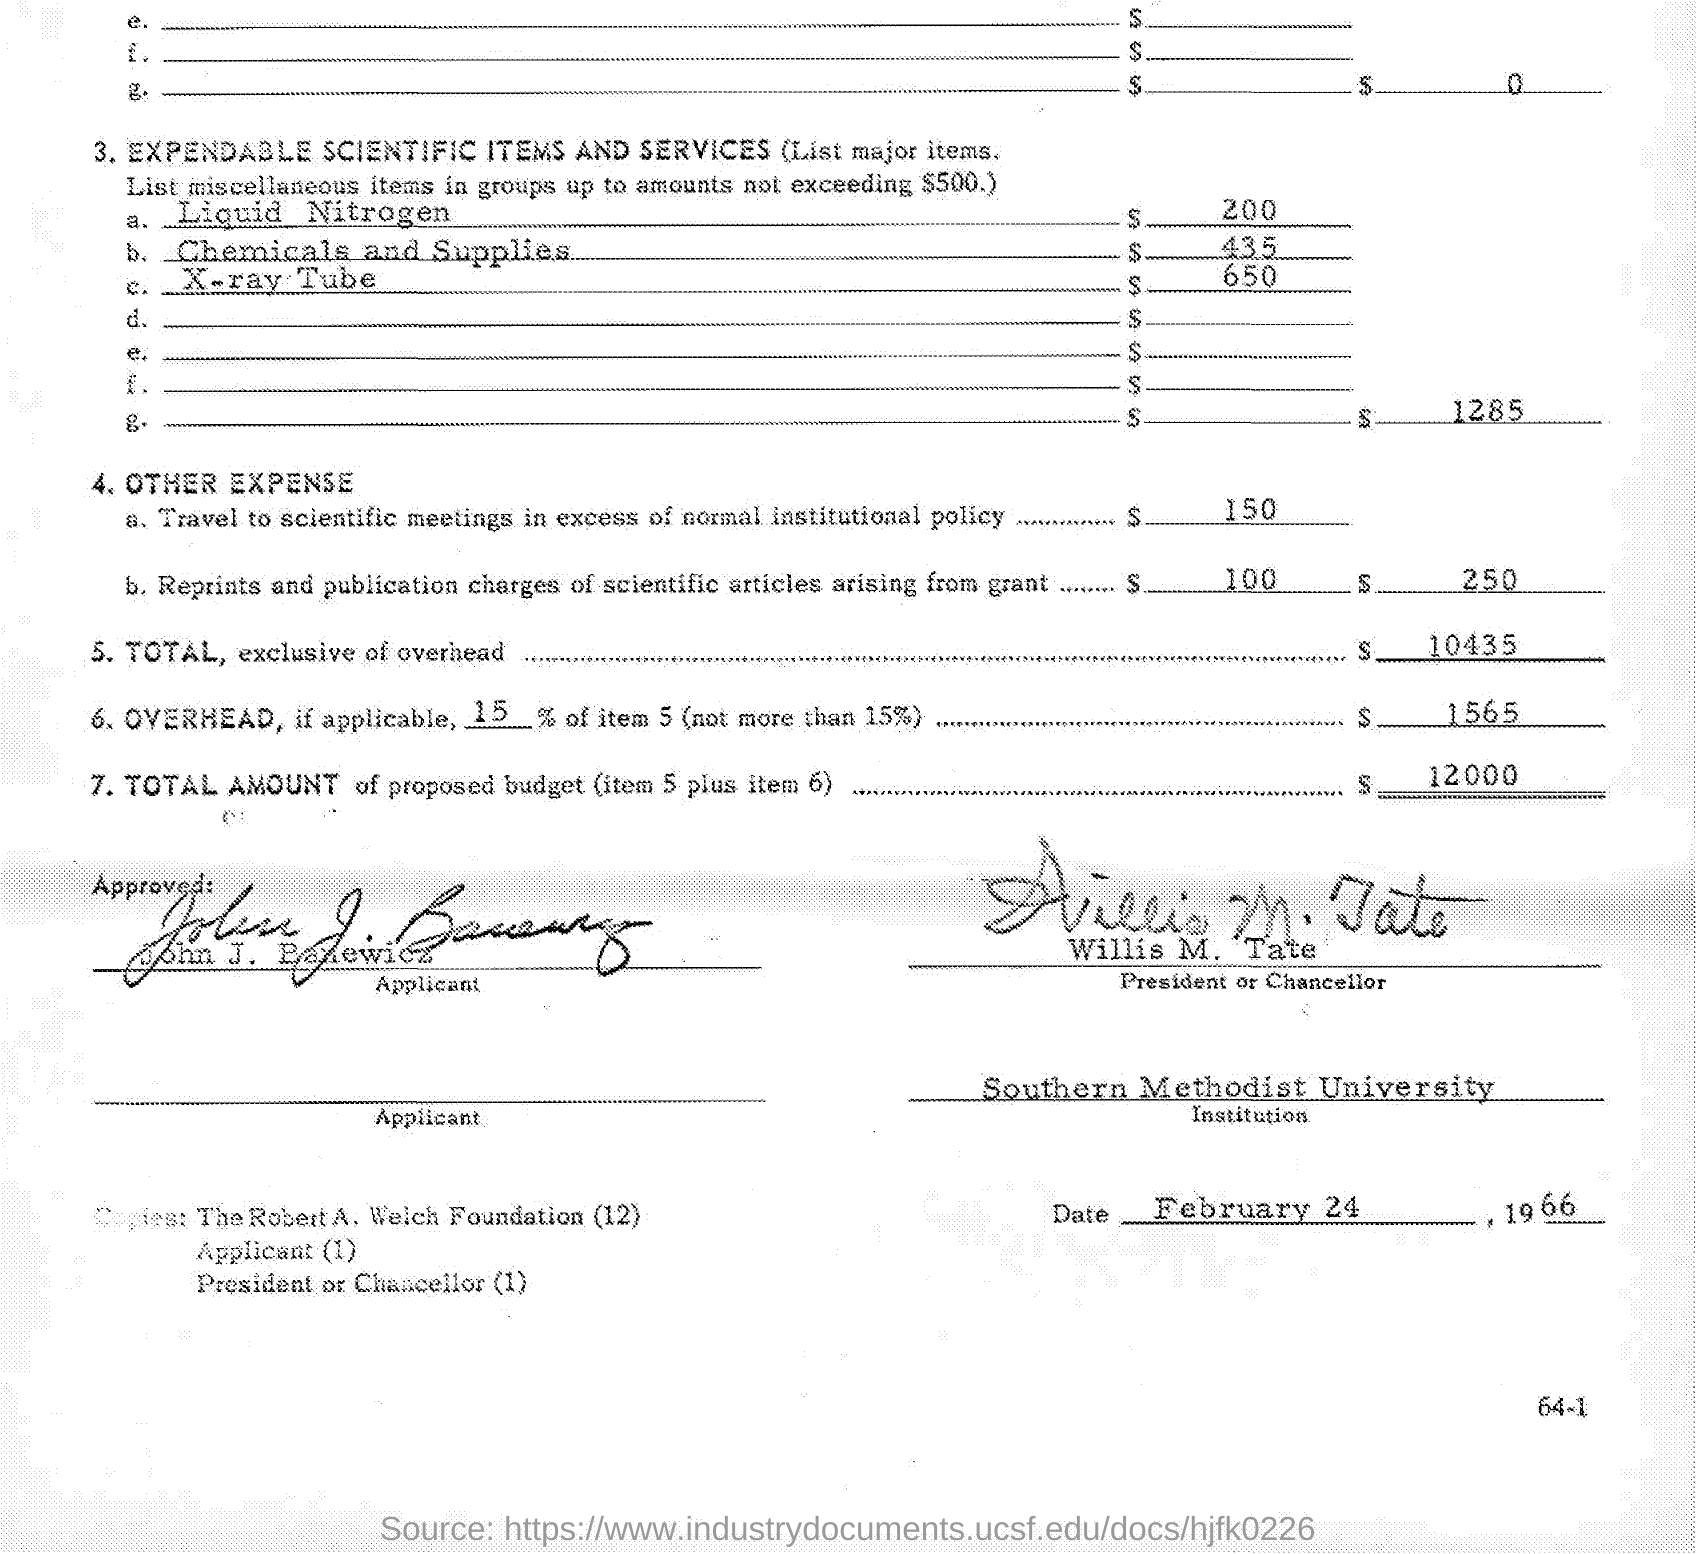Indicate a few pertinent items in this graphic. Southern Methodist University is mentioned. The document is dated February 24, 1966. The total, excluding overhead, is $10,435. Willis M. Tate is the President or Chancellor. 